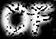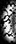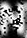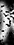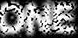What words can you see in these images in sequence, separated by a semicolon? OF; (; N; ); ONE 